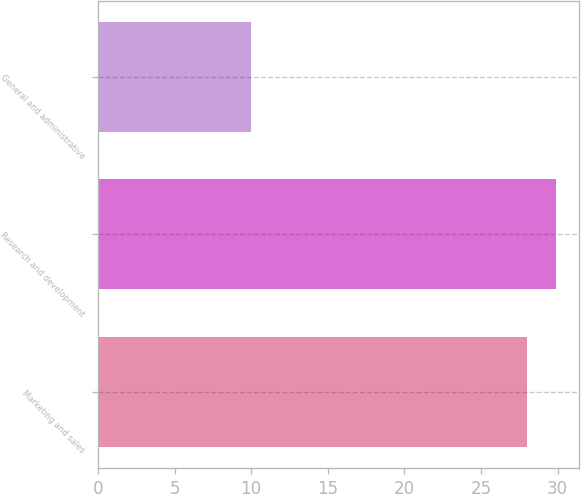Convert chart to OTSL. <chart><loc_0><loc_0><loc_500><loc_500><bar_chart><fcel>Marketing and sales<fcel>Research and development<fcel>General and administrative<nl><fcel>28<fcel>29.9<fcel>10<nl></chart> 